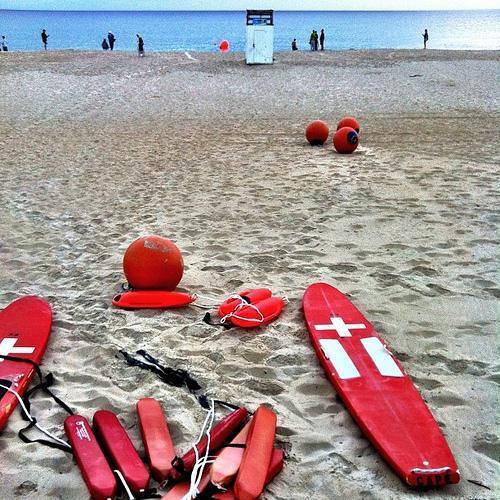How many surfboards are visible in the scene?
Give a very brief answer. 2. How many red balls are visible in the scene?
Give a very brief answer. 4. How many people are in the scene?
Give a very brief answer. 10. 